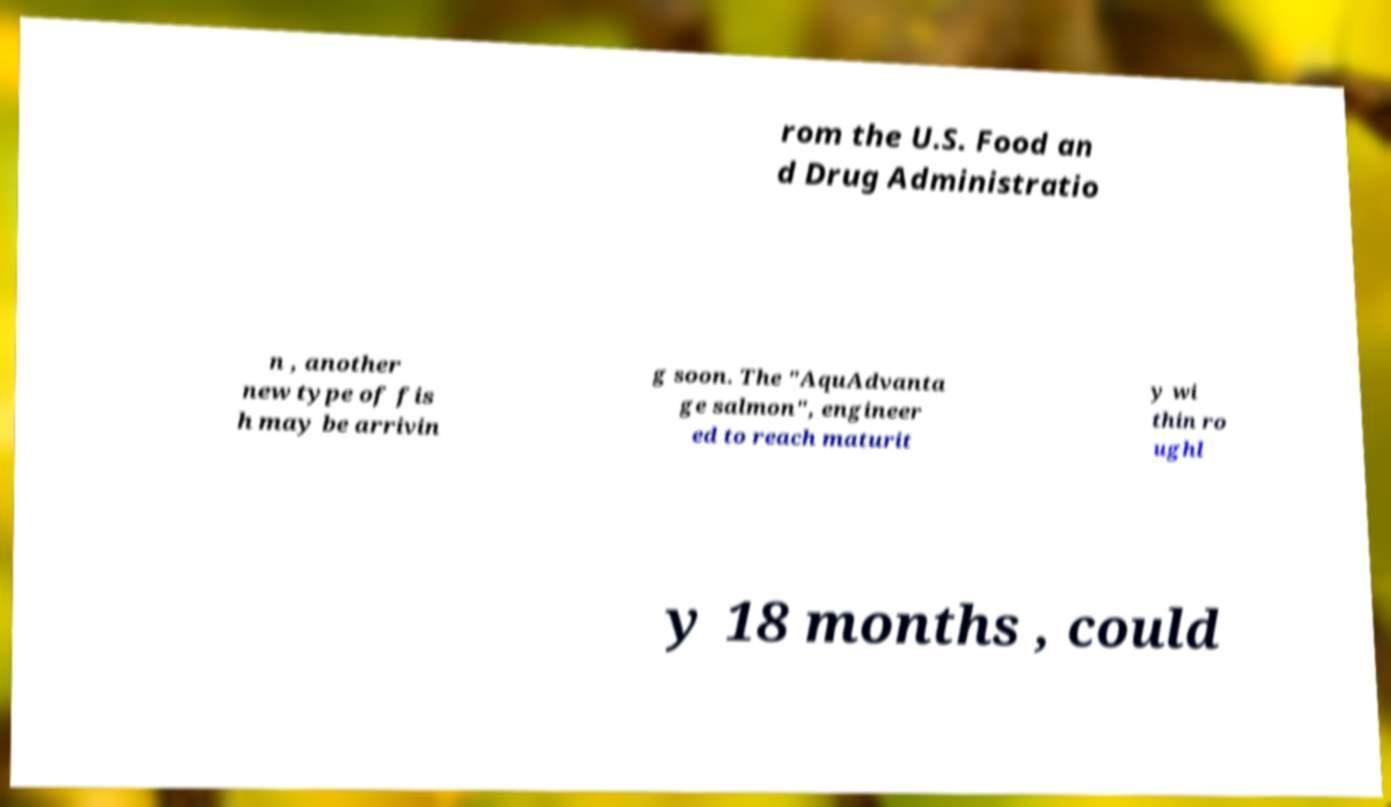Please read and relay the text visible in this image. What does it say? rom the U.S. Food an d Drug Administratio n , another new type of fis h may be arrivin g soon. The "AquAdvanta ge salmon", engineer ed to reach maturit y wi thin ro ughl y 18 months , could 